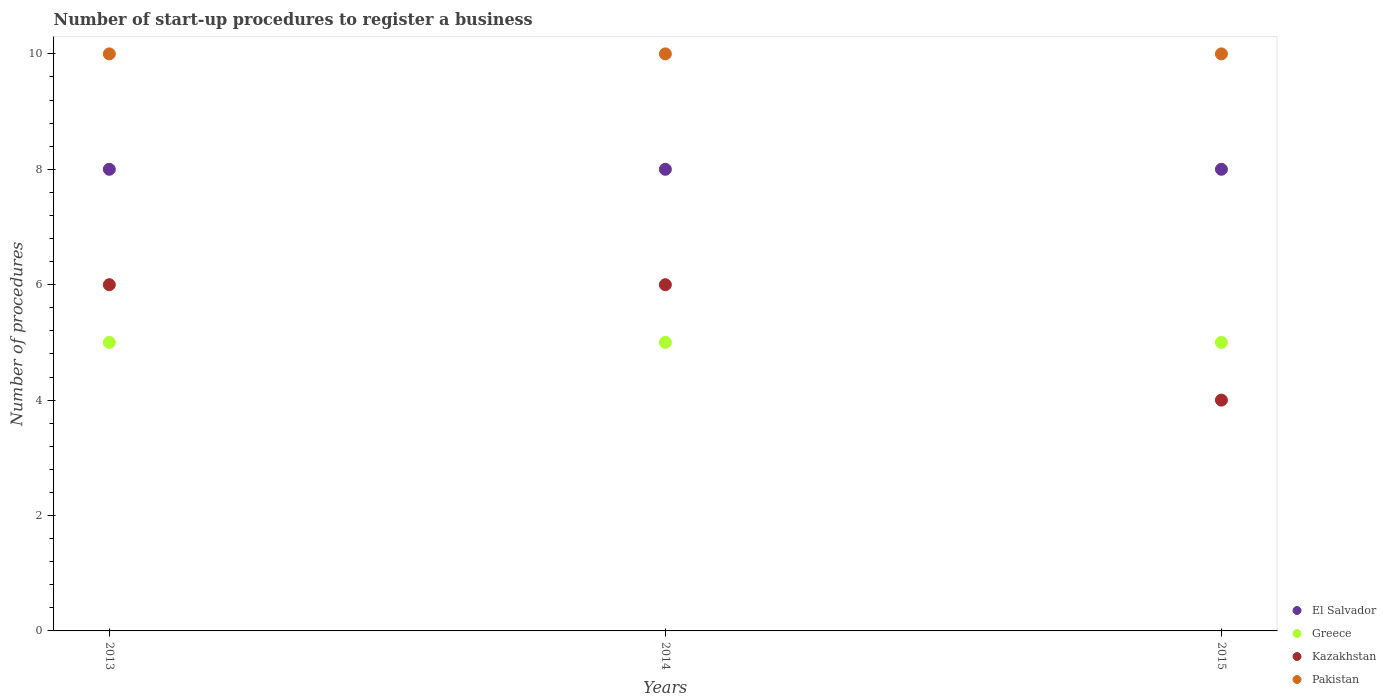What is the number of procedures required to register a business in Pakistan in 2015?
Ensure brevity in your answer.  10. Across all years, what is the minimum number of procedures required to register a business in Greece?
Ensure brevity in your answer.  5. In which year was the number of procedures required to register a business in El Salvador minimum?
Your answer should be compact. 2013. What is the total number of procedures required to register a business in El Salvador in the graph?
Offer a very short reply. 24. What is the difference between the number of procedures required to register a business in Greece in 2015 and the number of procedures required to register a business in Pakistan in 2014?
Make the answer very short. -5. In the year 2013, what is the difference between the number of procedures required to register a business in El Salvador and number of procedures required to register a business in Kazakhstan?
Your answer should be very brief. 2. In how many years, is the number of procedures required to register a business in Pakistan greater than 2?
Your answer should be compact. 3. Is the number of procedures required to register a business in Pakistan in 2013 less than that in 2015?
Your answer should be compact. No. What is the difference between the highest and the second highest number of procedures required to register a business in Kazakhstan?
Your response must be concise. 0. What is the difference between the highest and the lowest number of procedures required to register a business in Pakistan?
Your answer should be very brief. 0. In how many years, is the number of procedures required to register a business in Kazakhstan greater than the average number of procedures required to register a business in Kazakhstan taken over all years?
Offer a very short reply. 2. Is it the case that in every year, the sum of the number of procedures required to register a business in Kazakhstan and number of procedures required to register a business in Greece  is greater than the sum of number of procedures required to register a business in El Salvador and number of procedures required to register a business in Pakistan?
Ensure brevity in your answer.  No. Does the number of procedures required to register a business in Greece monotonically increase over the years?
Offer a very short reply. No. How many years are there in the graph?
Your answer should be compact. 3. How many legend labels are there?
Keep it short and to the point. 4. What is the title of the graph?
Your answer should be very brief. Number of start-up procedures to register a business. What is the label or title of the Y-axis?
Your answer should be very brief. Number of procedures. What is the Number of procedures in Greece in 2013?
Your answer should be very brief. 5. What is the Number of procedures in Kazakhstan in 2013?
Offer a terse response. 6. What is the Number of procedures in Pakistan in 2014?
Ensure brevity in your answer.  10. What is the Number of procedures in El Salvador in 2015?
Your answer should be very brief. 8. What is the Number of procedures in Kazakhstan in 2015?
Make the answer very short. 4. Across all years, what is the maximum Number of procedures in Pakistan?
Your answer should be very brief. 10. Across all years, what is the minimum Number of procedures of El Salvador?
Provide a short and direct response. 8. Across all years, what is the minimum Number of procedures of Greece?
Make the answer very short. 5. What is the total Number of procedures of Greece in the graph?
Give a very brief answer. 15. What is the difference between the Number of procedures in Greece in 2013 and that in 2014?
Provide a succinct answer. 0. What is the difference between the Number of procedures in Kazakhstan in 2013 and that in 2014?
Give a very brief answer. 0. What is the difference between the Number of procedures in El Salvador in 2013 and that in 2015?
Make the answer very short. 0. What is the difference between the Number of procedures of Greece in 2013 and that in 2015?
Offer a terse response. 0. What is the difference between the Number of procedures of Kazakhstan in 2013 and that in 2015?
Provide a succinct answer. 2. What is the difference between the Number of procedures in Pakistan in 2013 and that in 2015?
Offer a very short reply. 0. What is the difference between the Number of procedures in Kazakhstan in 2014 and that in 2015?
Your answer should be compact. 2. What is the difference between the Number of procedures of Pakistan in 2014 and that in 2015?
Provide a succinct answer. 0. What is the difference between the Number of procedures in El Salvador in 2013 and the Number of procedures in Greece in 2014?
Give a very brief answer. 3. What is the difference between the Number of procedures in El Salvador in 2013 and the Number of procedures in Pakistan in 2014?
Provide a succinct answer. -2. What is the difference between the Number of procedures of Greece in 2013 and the Number of procedures of Kazakhstan in 2014?
Give a very brief answer. -1. What is the difference between the Number of procedures of Kazakhstan in 2013 and the Number of procedures of Pakistan in 2014?
Ensure brevity in your answer.  -4. What is the difference between the Number of procedures in Greece in 2013 and the Number of procedures in Kazakhstan in 2015?
Your answer should be very brief. 1. What is the difference between the Number of procedures in Kazakhstan in 2013 and the Number of procedures in Pakistan in 2015?
Offer a terse response. -4. What is the difference between the Number of procedures of El Salvador in 2014 and the Number of procedures of Greece in 2015?
Offer a very short reply. 3. What is the difference between the Number of procedures of El Salvador in 2014 and the Number of procedures of Kazakhstan in 2015?
Keep it short and to the point. 4. What is the difference between the Number of procedures in El Salvador in 2014 and the Number of procedures in Pakistan in 2015?
Offer a terse response. -2. What is the difference between the Number of procedures of Greece in 2014 and the Number of procedures of Kazakhstan in 2015?
Your answer should be very brief. 1. What is the difference between the Number of procedures of Greece in 2014 and the Number of procedures of Pakistan in 2015?
Provide a short and direct response. -5. What is the average Number of procedures in El Salvador per year?
Offer a terse response. 8. What is the average Number of procedures of Kazakhstan per year?
Offer a terse response. 5.33. In the year 2013, what is the difference between the Number of procedures in El Salvador and Number of procedures in Greece?
Give a very brief answer. 3. In the year 2013, what is the difference between the Number of procedures in El Salvador and Number of procedures in Kazakhstan?
Your answer should be compact. 2. In the year 2013, what is the difference between the Number of procedures in Greece and Number of procedures in Kazakhstan?
Offer a very short reply. -1. In the year 2013, what is the difference between the Number of procedures in Kazakhstan and Number of procedures in Pakistan?
Make the answer very short. -4. In the year 2014, what is the difference between the Number of procedures in El Salvador and Number of procedures in Greece?
Give a very brief answer. 3. In the year 2014, what is the difference between the Number of procedures of El Salvador and Number of procedures of Pakistan?
Your answer should be very brief. -2. In the year 2014, what is the difference between the Number of procedures of Greece and Number of procedures of Pakistan?
Provide a succinct answer. -5. In the year 2014, what is the difference between the Number of procedures in Kazakhstan and Number of procedures in Pakistan?
Offer a very short reply. -4. In the year 2015, what is the difference between the Number of procedures of El Salvador and Number of procedures of Greece?
Provide a short and direct response. 3. In the year 2015, what is the difference between the Number of procedures in El Salvador and Number of procedures in Kazakhstan?
Provide a succinct answer. 4. In the year 2015, what is the difference between the Number of procedures of Greece and Number of procedures of Kazakhstan?
Your answer should be very brief. 1. In the year 2015, what is the difference between the Number of procedures of Greece and Number of procedures of Pakistan?
Keep it short and to the point. -5. In the year 2015, what is the difference between the Number of procedures of Kazakhstan and Number of procedures of Pakistan?
Offer a very short reply. -6. What is the ratio of the Number of procedures of Greece in 2013 to that in 2014?
Ensure brevity in your answer.  1. What is the ratio of the Number of procedures of Kazakhstan in 2013 to that in 2014?
Give a very brief answer. 1. What is the ratio of the Number of procedures of Greece in 2013 to that in 2015?
Provide a short and direct response. 1. What is the ratio of the Number of procedures of Kazakhstan in 2013 to that in 2015?
Your answer should be very brief. 1.5. What is the ratio of the Number of procedures in Pakistan in 2013 to that in 2015?
Keep it short and to the point. 1. What is the ratio of the Number of procedures in El Salvador in 2014 to that in 2015?
Offer a terse response. 1. What is the ratio of the Number of procedures in Pakistan in 2014 to that in 2015?
Keep it short and to the point. 1. What is the difference between the highest and the second highest Number of procedures in El Salvador?
Your answer should be compact. 0. What is the difference between the highest and the second highest Number of procedures of Greece?
Provide a short and direct response. 0. What is the difference between the highest and the second highest Number of procedures in Kazakhstan?
Ensure brevity in your answer.  0. What is the difference between the highest and the second highest Number of procedures in Pakistan?
Ensure brevity in your answer.  0. What is the difference between the highest and the lowest Number of procedures of El Salvador?
Offer a terse response. 0. What is the difference between the highest and the lowest Number of procedures of Kazakhstan?
Your answer should be compact. 2. 